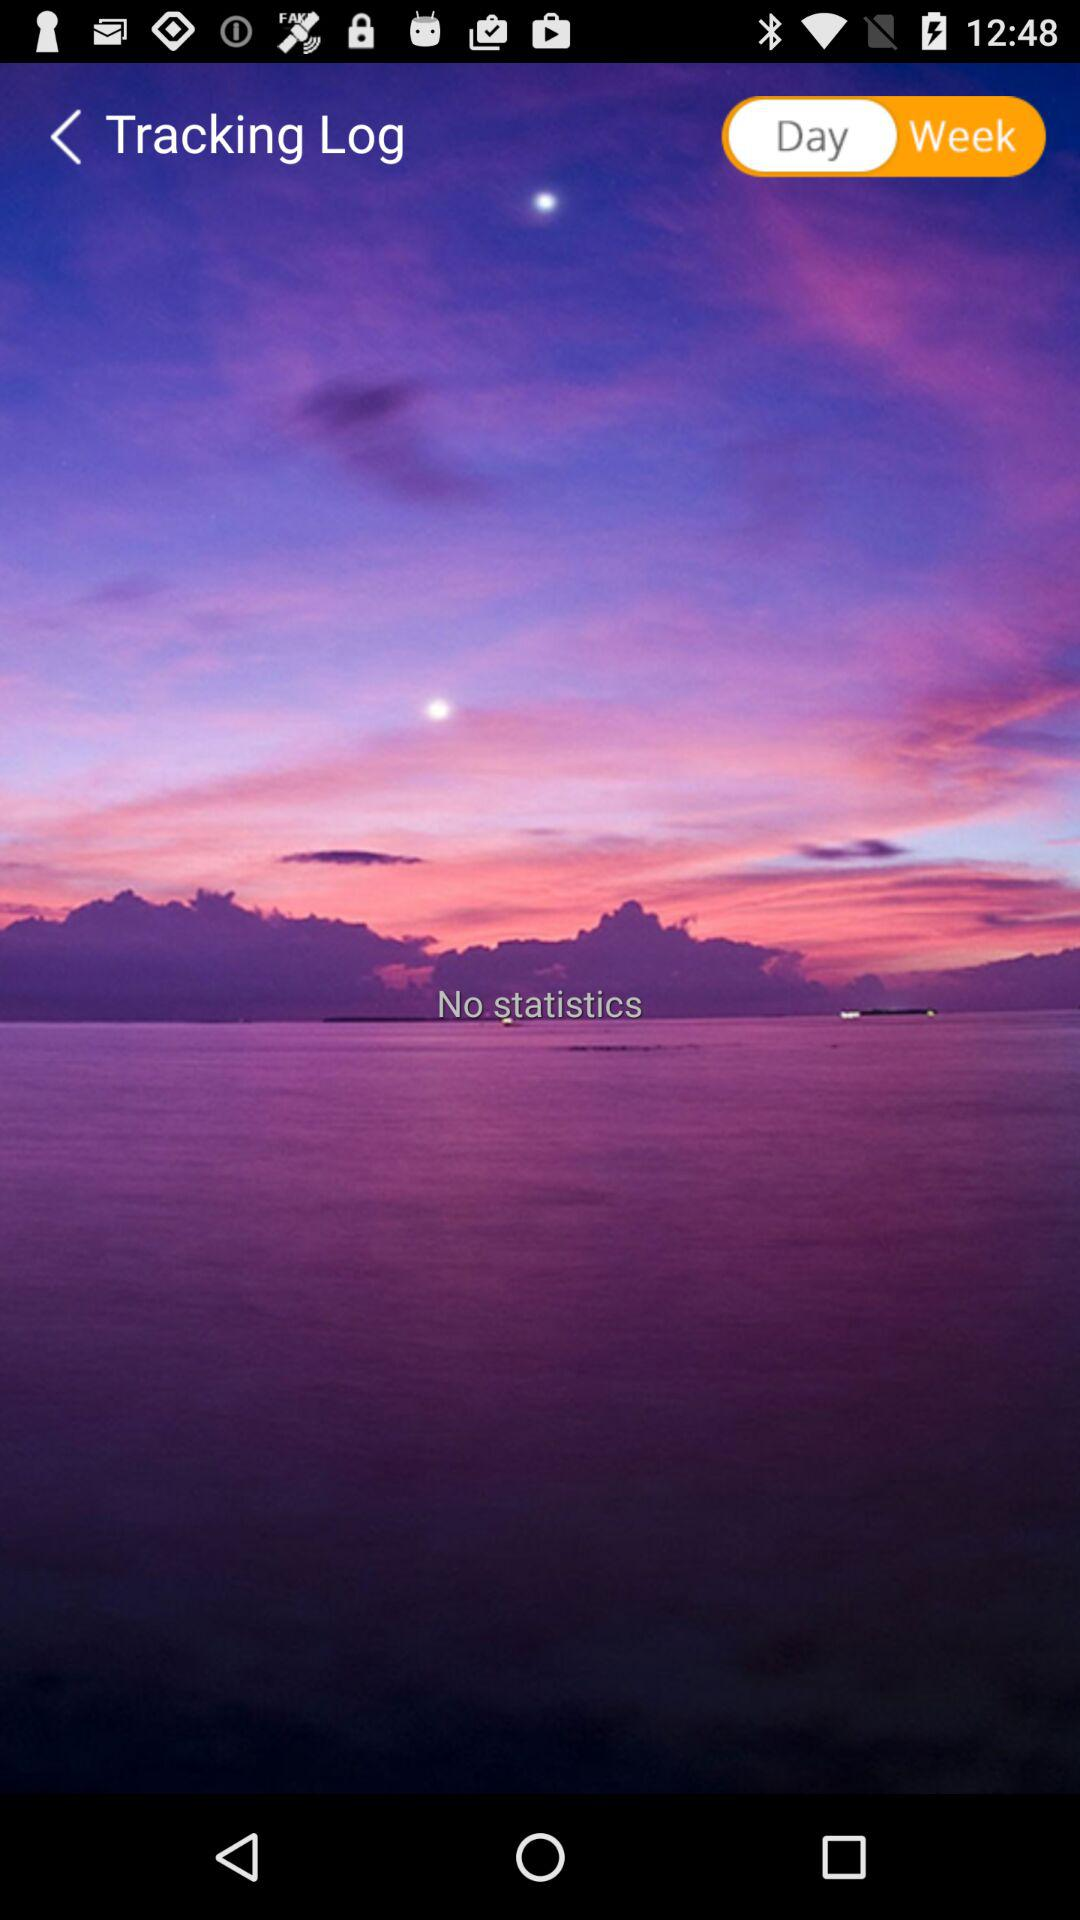Is there any statistic? There are no statistics. 